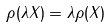Convert formula to latex. <formula><loc_0><loc_0><loc_500><loc_500>\rho ( \lambda X ) = \lambda \rho ( X )</formula> 